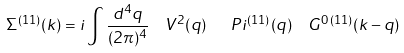<formula> <loc_0><loc_0><loc_500><loc_500>\Sigma ^ { ( 1 1 ) } ( k ) = i \int \frac { d ^ { 4 } q } { ( 2 \pi ) ^ { 4 } } \ \ V ^ { 2 } ( q ) \ \ \ P i ^ { ( 1 1 ) } ( q ) \ \ G ^ { 0 \, ( 1 1 ) } ( k - q )</formula> 